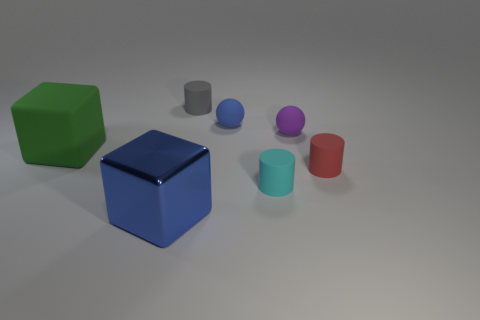Subtract all red rubber cylinders. How many cylinders are left? 2 Subtract all gray cylinders. How many cylinders are left? 2 Subtract all spheres. How many objects are left? 5 Subtract 2 cubes. How many cubes are left? 0 Add 2 cyan cylinders. How many objects exist? 9 Subtract 0 green spheres. How many objects are left? 7 Subtract all blue balls. Subtract all purple cylinders. How many balls are left? 1 Subtract all yellow objects. Subtract all small rubber things. How many objects are left? 2 Add 4 big blue cubes. How many big blue cubes are left? 5 Add 1 red cylinders. How many red cylinders exist? 2 